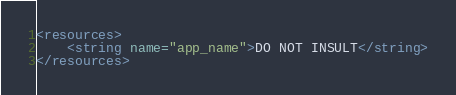<code> <loc_0><loc_0><loc_500><loc_500><_XML_><resources>
    <string name="app_name">DO NOT INSULT</string>
</resources>
</code> 